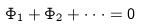Convert formula to latex. <formula><loc_0><loc_0><loc_500><loc_500>\Phi _ { 1 } + \Phi _ { 2 } + \cdot \cdot \cdot = 0</formula> 